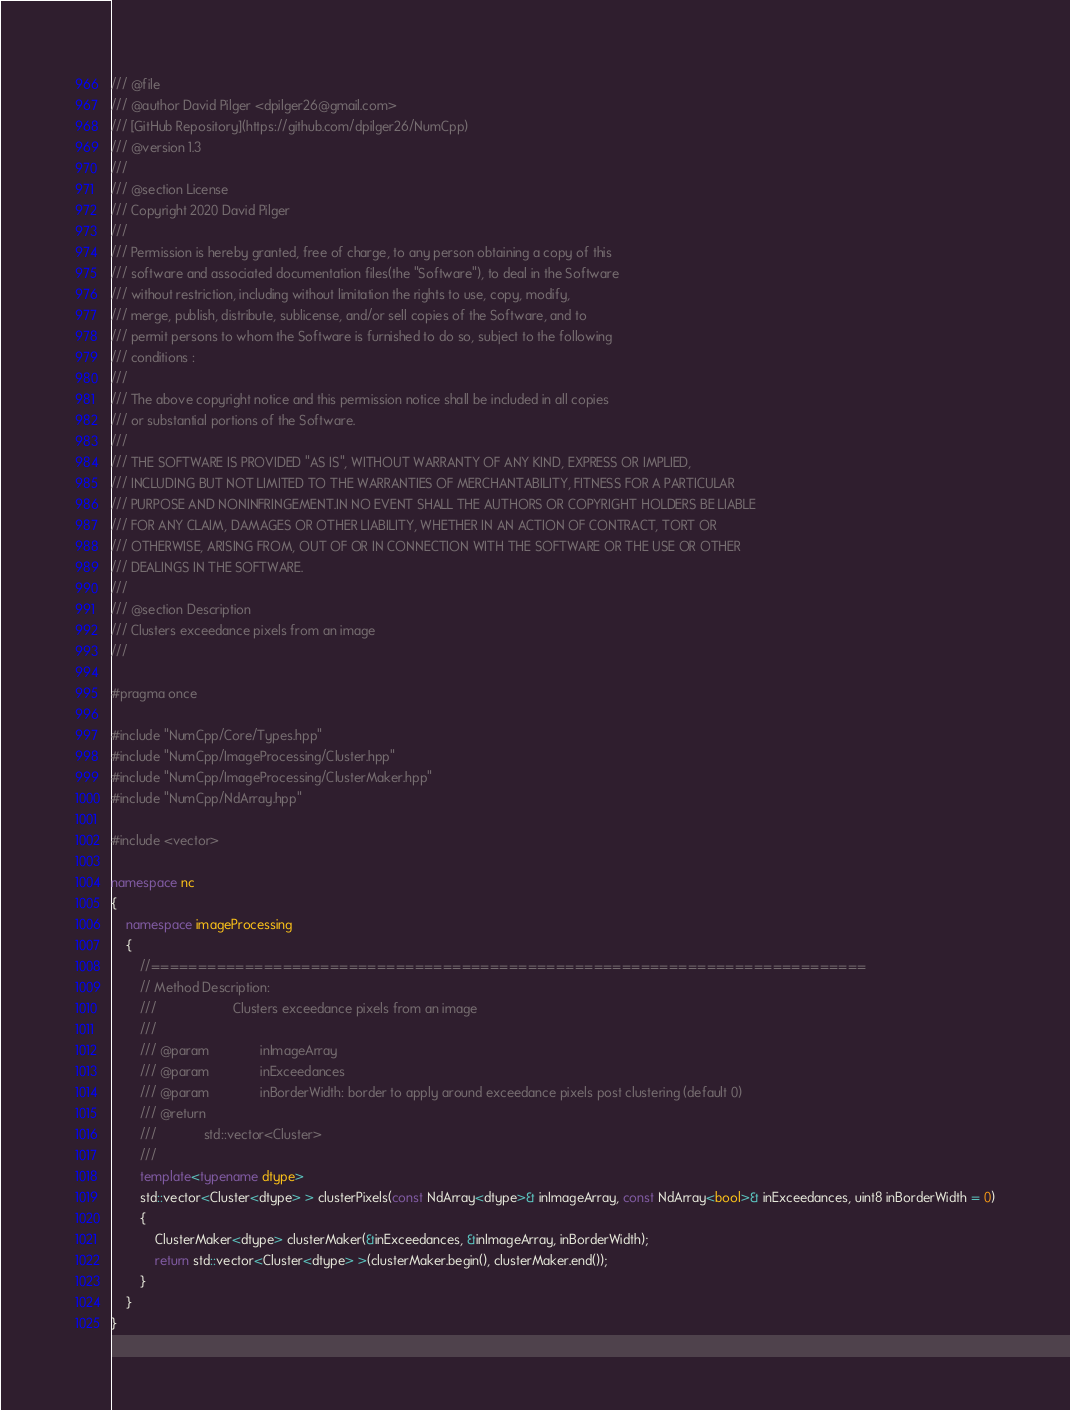Convert code to text. <code><loc_0><loc_0><loc_500><loc_500><_C++_>/// @file
/// @author David Pilger <dpilger26@gmail.com>
/// [GitHub Repository](https://github.com/dpilger26/NumCpp)
/// @version 1.3
///
/// @section License
/// Copyright 2020 David Pilger
///
/// Permission is hereby granted, free of charge, to any person obtaining a copy of this
/// software and associated documentation files(the "Software"), to deal in the Software
/// without restriction, including without limitation the rights to use, copy, modify,
/// merge, publish, distribute, sublicense, and/or sell copies of the Software, and to
/// permit persons to whom the Software is furnished to do so, subject to the following
/// conditions :
///
/// The above copyright notice and this permission notice shall be included in all copies
/// or substantial portions of the Software.
///
/// THE SOFTWARE IS PROVIDED "AS IS", WITHOUT WARRANTY OF ANY KIND, EXPRESS OR IMPLIED,
/// INCLUDING BUT NOT LIMITED TO THE WARRANTIES OF MERCHANTABILITY, FITNESS FOR A PARTICULAR
/// PURPOSE AND NONINFRINGEMENT.IN NO EVENT SHALL THE AUTHORS OR COPYRIGHT HOLDERS BE LIABLE
/// FOR ANY CLAIM, DAMAGES OR OTHER LIABILITY, WHETHER IN AN ACTION OF CONTRACT, TORT OR
/// OTHERWISE, ARISING FROM, OUT OF OR IN CONNECTION WITH THE SOFTWARE OR THE USE OR OTHER
/// DEALINGS IN THE SOFTWARE.
///
/// @section Description
/// Clusters exceedance pixels from an image
///

#pragma once

#include "NumCpp/Core/Types.hpp"
#include "NumCpp/ImageProcessing/Cluster.hpp"
#include "NumCpp/ImageProcessing/ClusterMaker.hpp"
#include "NumCpp/NdArray.hpp"

#include <vector>

namespace nc
{
    namespace imageProcessing
    {
        //============================================================================
        // Method Description:
        ///						Clusters exceedance pixels from an image
        ///
        /// @param				inImageArray
        /// @param				inExceedances
        /// @param				inBorderWidth: border to apply around exceedance pixels post clustering (default 0)
        /// @return
        ///				std::vector<Cluster>
        ///
        template<typename dtype>
        std::vector<Cluster<dtype> > clusterPixels(const NdArray<dtype>& inImageArray, const NdArray<bool>& inExceedances, uint8 inBorderWidth = 0)
        {
            ClusterMaker<dtype> clusterMaker(&inExceedances, &inImageArray, inBorderWidth);
            return std::vector<Cluster<dtype> >(clusterMaker.begin(), clusterMaker.end());
        }
    }
}
</code> 